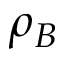Convert formula to latex. <formula><loc_0><loc_0><loc_500><loc_500>\rho _ { B }</formula> 